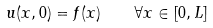<formula> <loc_0><loc_0><loc_500><loc_500>u ( x , 0 ) = f ( x ) \quad \forall x \in [ 0 , L ]</formula> 